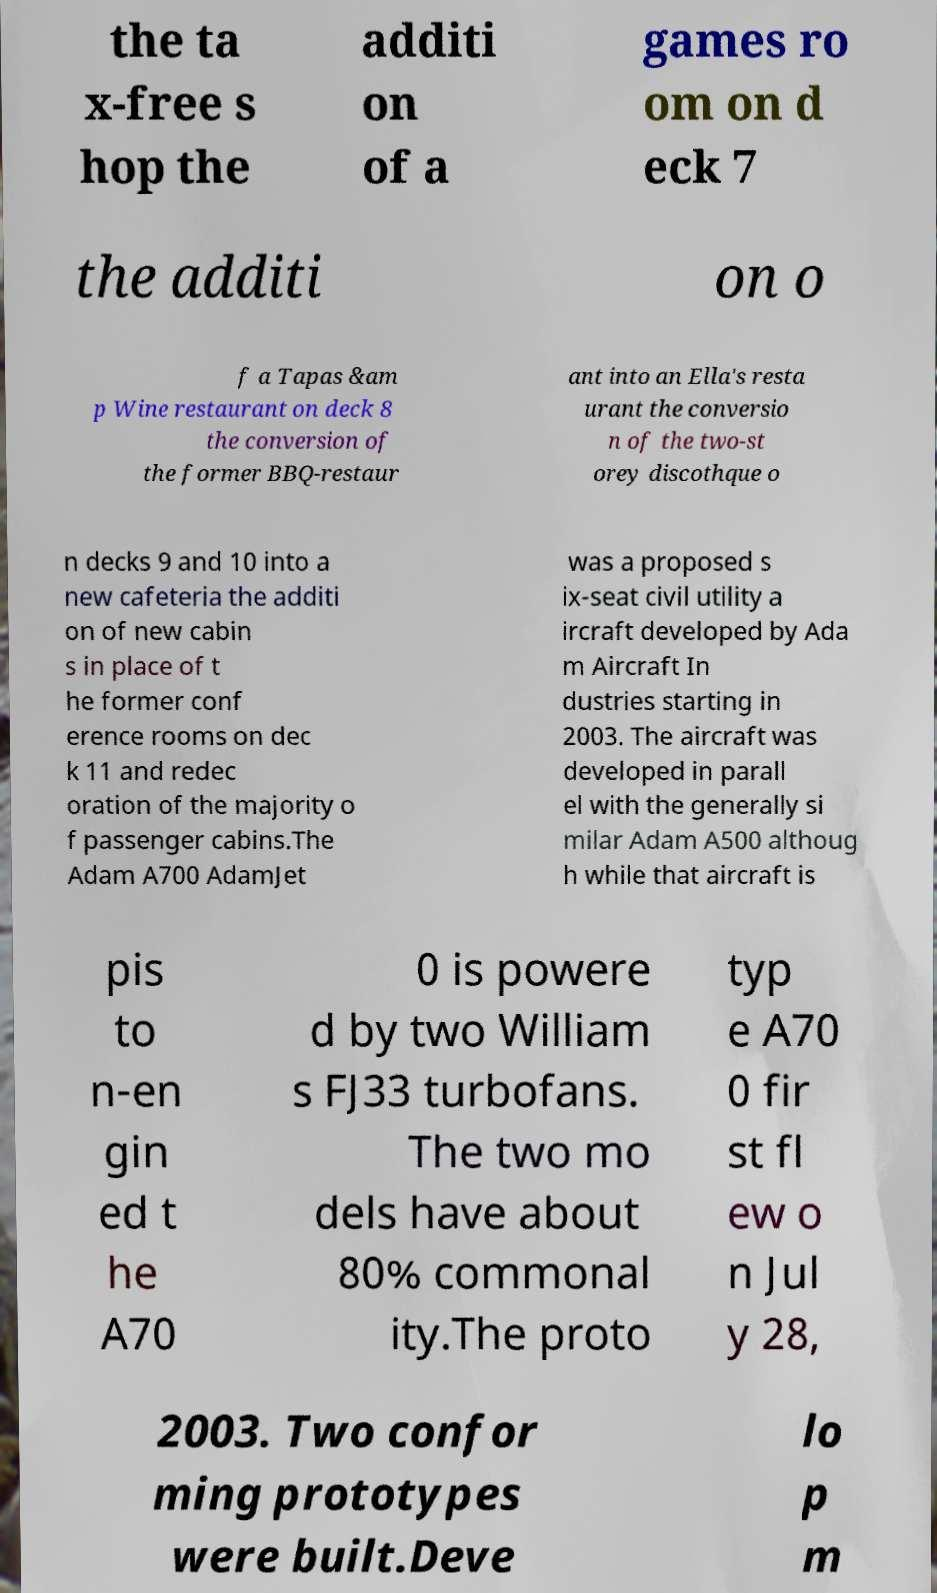What messages or text are displayed in this image? I need them in a readable, typed format. the ta x-free s hop the additi on of a games ro om on d eck 7 the additi on o f a Tapas &am p Wine restaurant on deck 8 the conversion of the former BBQ-restaur ant into an Ella's resta urant the conversio n of the two-st orey discothque o n decks 9 and 10 into a new cafeteria the additi on of new cabin s in place of t he former conf erence rooms on dec k 11 and redec oration of the majority o f passenger cabins.The Adam A700 AdamJet was a proposed s ix-seat civil utility a ircraft developed by Ada m Aircraft In dustries starting in 2003. The aircraft was developed in parall el with the generally si milar Adam A500 althoug h while that aircraft is pis to n-en gin ed t he A70 0 is powere d by two William s FJ33 turbofans. The two mo dels have about 80% commonal ity.The proto typ e A70 0 fir st fl ew o n Jul y 28, 2003. Two confor ming prototypes were built.Deve lo p m 